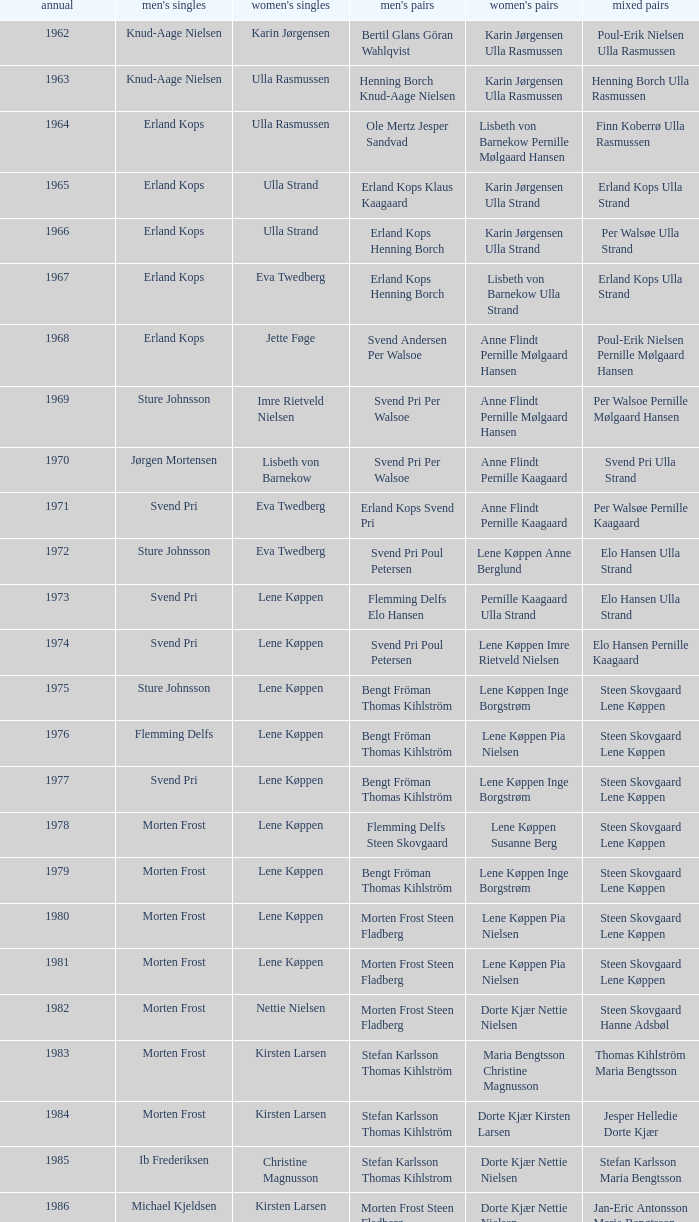Who won the men's doubles the year Pernille Nedergaard won the women's singles? Thomas Stuer-Lauridsen Max Gandrup. 